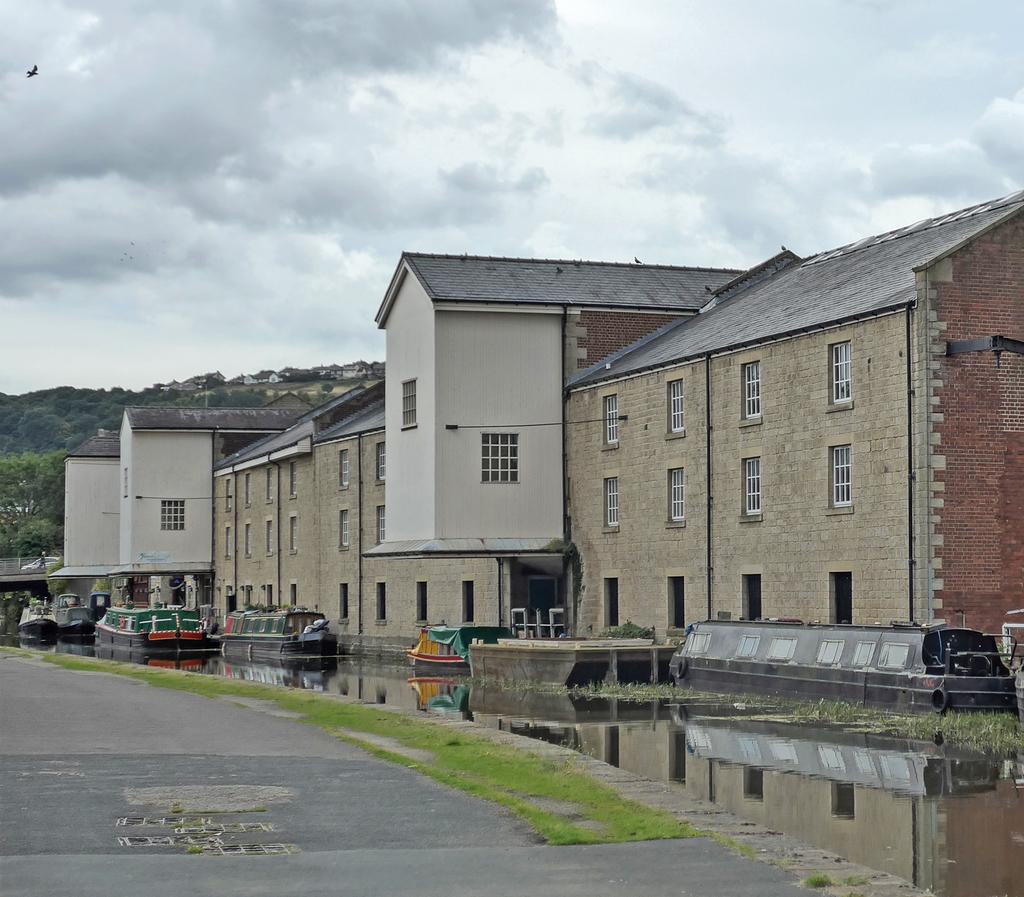How would you summarize this image in a sentence or two? There are buildings in the image. There is water. There is road at the bottom of the image. To the left side of the image there are trees. 